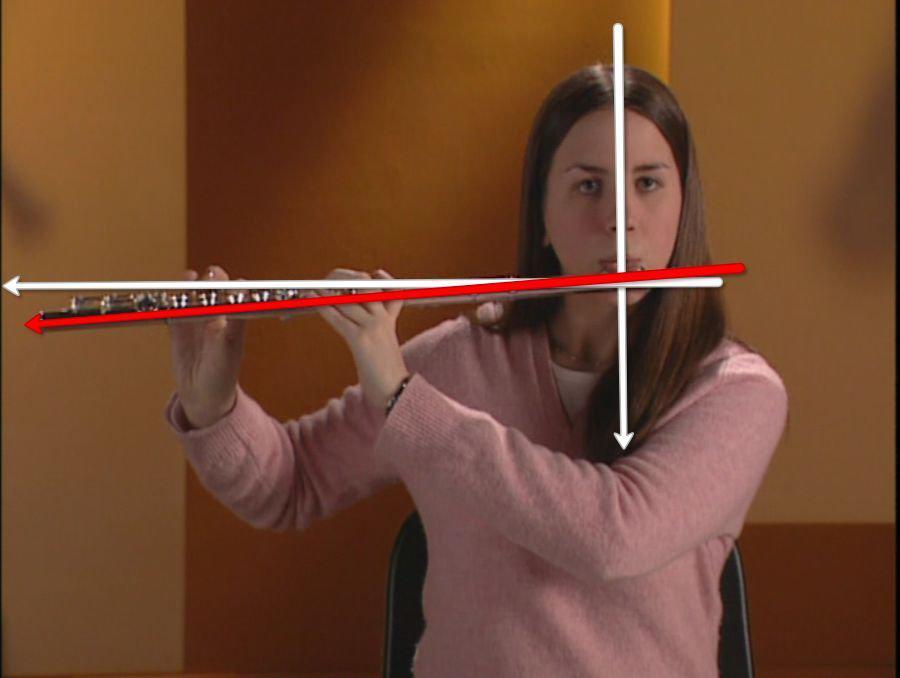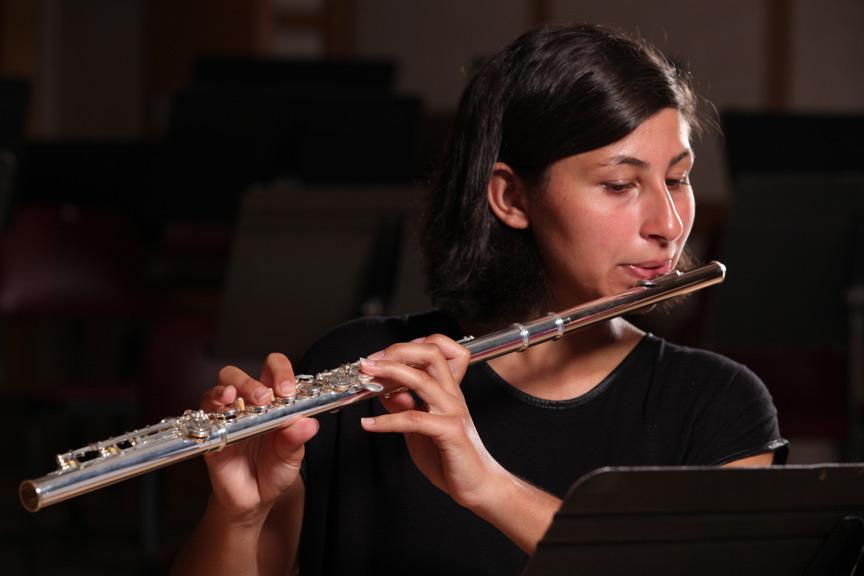The first image is the image on the left, the second image is the image on the right. Considering the images on both sides, is "There are two flute being played and the end is facing left." valid? Answer yes or no. Yes. The first image is the image on the left, the second image is the image on the right. Evaluate the accuracy of this statement regarding the images: "There are four hands.". Is it true? Answer yes or no. Yes. 